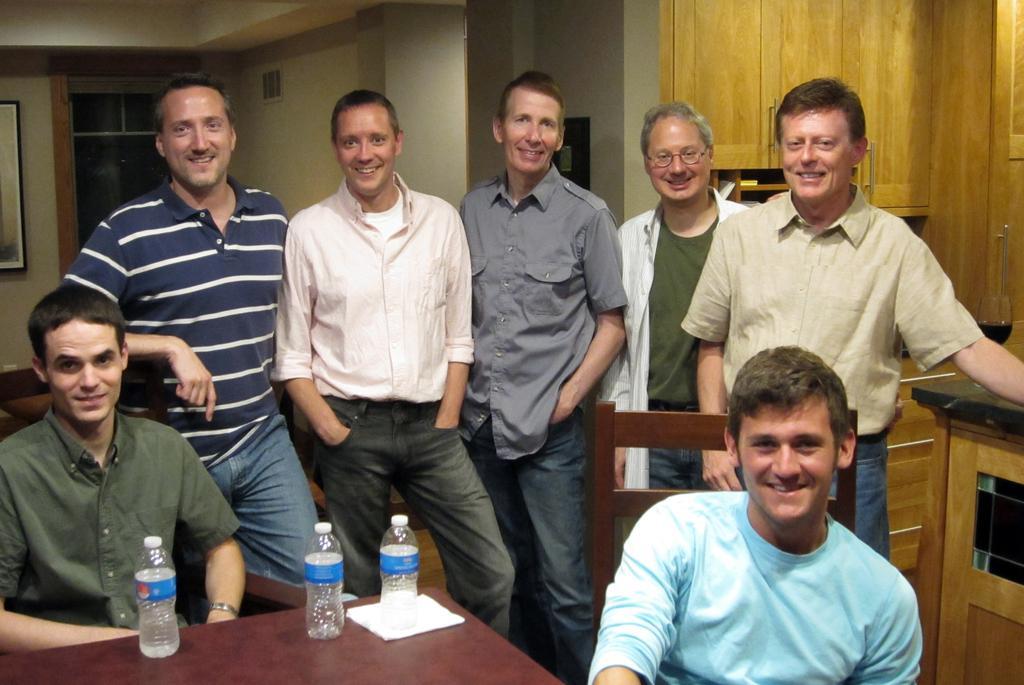Please provide a concise description of this image. In this image I can see two persons are sitting on chairs and number of persons are standing behind them. I can see a brown colored table with three bottles on it. I can see the wall, a photo frame attached to the wall and the window in the background. 